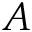<formula> <loc_0><loc_0><loc_500><loc_500>A</formula> 